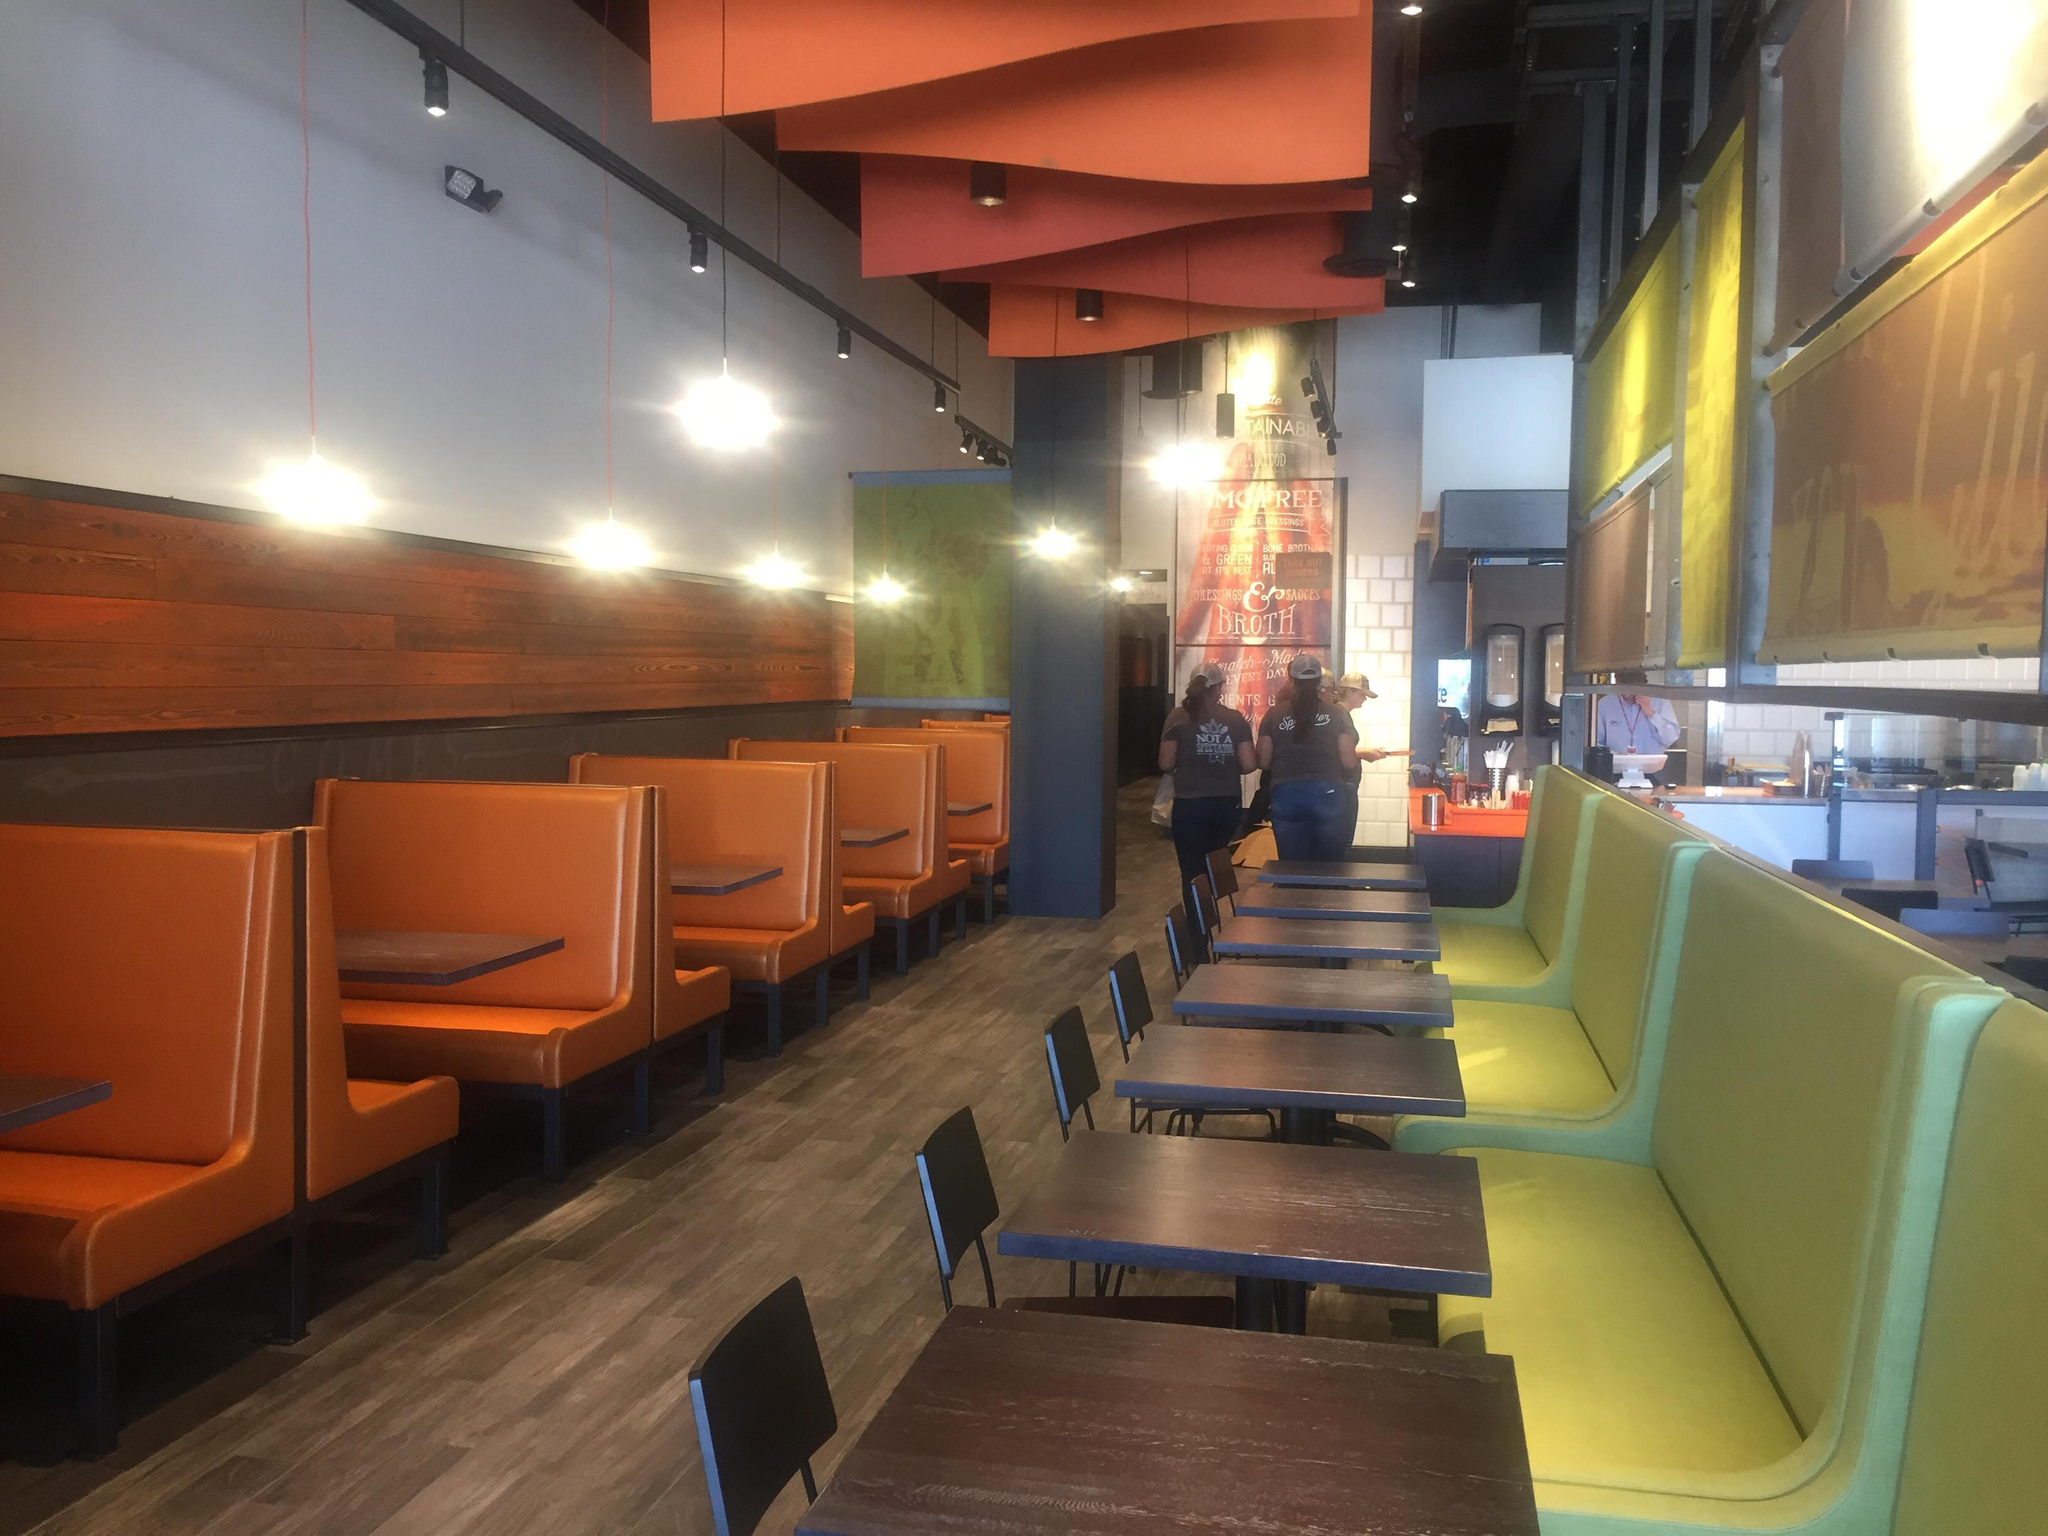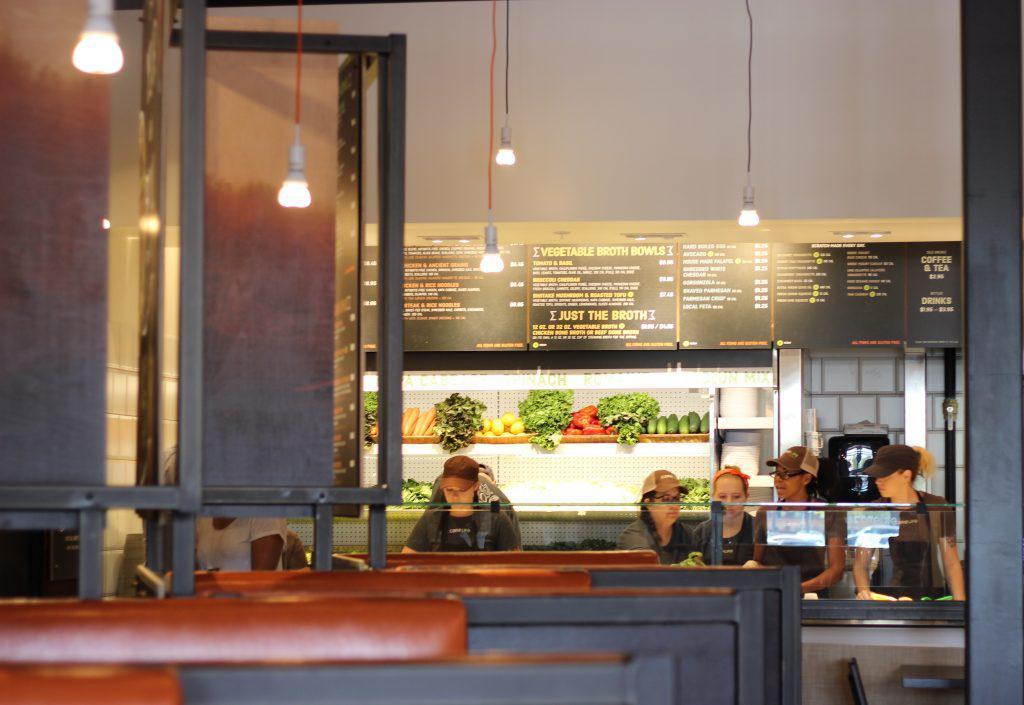The first image is the image on the left, the second image is the image on the right. Evaluate the accuracy of this statement regarding the images: "The left image shows two rows of seats with an aisle of wood-grain floor between them and angled architectural elements above them on the ceiling.". Is it true? Answer yes or no. Yes. The first image is the image on the left, the second image is the image on the right. Evaluate the accuracy of this statement regarding the images: "The left and right image contains a total of four salads in white bowls.". Is it true? Answer yes or no. No. 